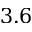Convert formula to latex. <formula><loc_0><loc_0><loc_500><loc_500>3 . 6</formula> 